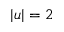<formula> <loc_0><loc_0><loc_500><loc_500>| u | = 2</formula> 